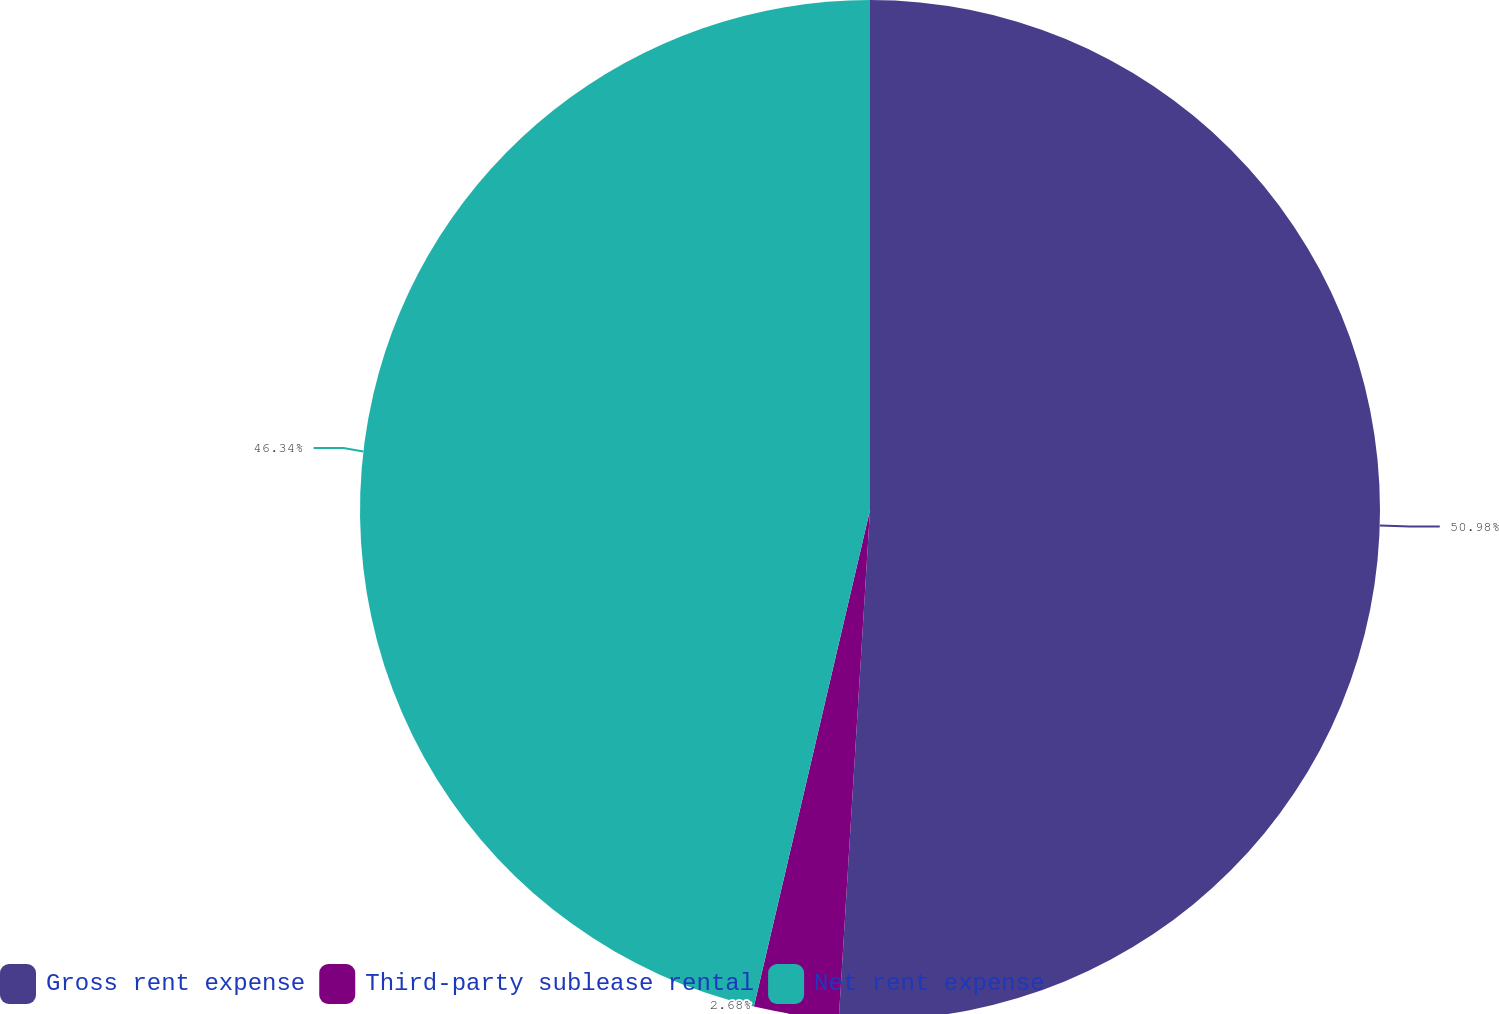Convert chart. <chart><loc_0><loc_0><loc_500><loc_500><pie_chart><fcel>Gross rent expense<fcel>Third-party sublease rental<fcel>Net rent expense<nl><fcel>50.97%<fcel>2.68%<fcel>46.34%<nl></chart> 